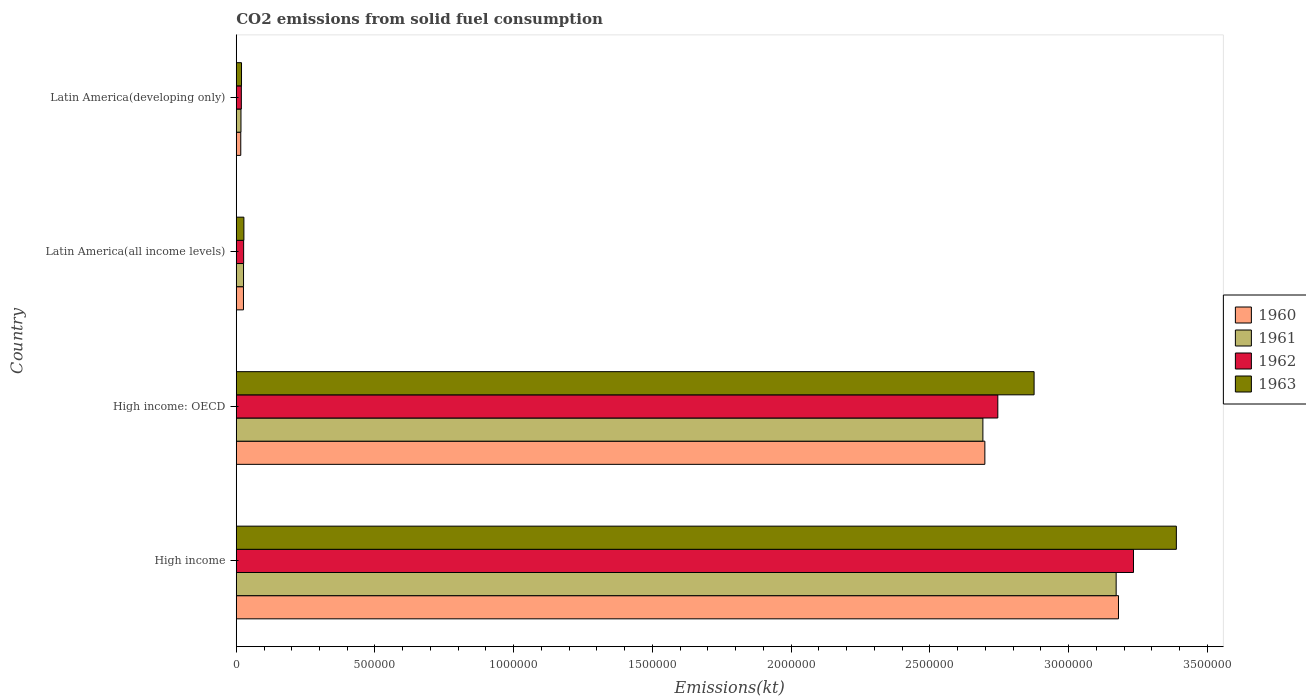How many different coloured bars are there?
Your response must be concise. 4. How many groups of bars are there?
Offer a terse response. 4. Are the number of bars per tick equal to the number of legend labels?
Offer a very short reply. Yes. How many bars are there on the 3rd tick from the top?
Give a very brief answer. 4. What is the label of the 2nd group of bars from the top?
Make the answer very short. Latin America(all income levels). What is the amount of CO2 emitted in 1960 in Latin America(all income levels)?
Offer a terse response. 2.60e+04. Across all countries, what is the maximum amount of CO2 emitted in 1960?
Offer a very short reply. 3.18e+06. Across all countries, what is the minimum amount of CO2 emitted in 1961?
Ensure brevity in your answer.  1.70e+04. In which country was the amount of CO2 emitted in 1961 minimum?
Give a very brief answer. Latin America(developing only). What is the total amount of CO2 emitted in 1960 in the graph?
Offer a terse response. 5.92e+06. What is the difference between the amount of CO2 emitted in 1960 in High income: OECD and that in Latin America(all income levels)?
Ensure brevity in your answer.  2.67e+06. What is the difference between the amount of CO2 emitted in 1960 in Latin America(all income levels) and the amount of CO2 emitted in 1962 in High income: OECD?
Keep it short and to the point. -2.72e+06. What is the average amount of CO2 emitted in 1962 per country?
Provide a short and direct response. 1.51e+06. What is the difference between the amount of CO2 emitted in 1961 and amount of CO2 emitted in 1963 in Latin America(developing only)?
Your answer should be very brief. -1990.54. In how many countries, is the amount of CO2 emitted in 1962 greater than 1500000 kt?
Offer a terse response. 2. What is the ratio of the amount of CO2 emitted in 1963 in High income to that in High income: OECD?
Ensure brevity in your answer.  1.18. What is the difference between the highest and the second highest amount of CO2 emitted in 1962?
Offer a very short reply. 4.89e+05. What is the difference between the highest and the lowest amount of CO2 emitted in 1960?
Offer a very short reply. 3.16e+06. In how many countries, is the amount of CO2 emitted in 1963 greater than the average amount of CO2 emitted in 1963 taken over all countries?
Ensure brevity in your answer.  2. Is the sum of the amount of CO2 emitted in 1962 in High income: OECD and Latin America(developing only) greater than the maximum amount of CO2 emitted in 1963 across all countries?
Make the answer very short. No. Are all the bars in the graph horizontal?
Your response must be concise. Yes. How many countries are there in the graph?
Your answer should be compact. 4. Does the graph contain grids?
Keep it short and to the point. No. Where does the legend appear in the graph?
Offer a very short reply. Center right. How are the legend labels stacked?
Give a very brief answer. Vertical. What is the title of the graph?
Make the answer very short. CO2 emissions from solid fuel consumption. What is the label or title of the X-axis?
Make the answer very short. Emissions(kt). What is the label or title of the Y-axis?
Provide a succinct answer. Country. What is the Emissions(kt) of 1960 in High income?
Offer a very short reply. 3.18e+06. What is the Emissions(kt) of 1961 in High income?
Keep it short and to the point. 3.17e+06. What is the Emissions(kt) of 1962 in High income?
Offer a terse response. 3.23e+06. What is the Emissions(kt) in 1963 in High income?
Your response must be concise. 3.39e+06. What is the Emissions(kt) of 1960 in High income: OECD?
Your answer should be compact. 2.70e+06. What is the Emissions(kt) in 1961 in High income: OECD?
Give a very brief answer. 2.69e+06. What is the Emissions(kt) in 1962 in High income: OECD?
Your answer should be compact. 2.75e+06. What is the Emissions(kt) of 1963 in High income: OECD?
Your response must be concise. 2.88e+06. What is the Emissions(kt) in 1960 in Latin America(all income levels)?
Your answer should be very brief. 2.60e+04. What is the Emissions(kt) of 1961 in Latin America(all income levels)?
Your answer should be compact. 2.63e+04. What is the Emissions(kt) in 1962 in Latin America(all income levels)?
Make the answer very short. 2.67e+04. What is the Emissions(kt) in 1963 in Latin America(all income levels)?
Your answer should be compact. 2.75e+04. What is the Emissions(kt) of 1960 in Latin America(developing only)?
Provide a short and direct response. 1.62e+04. What is the Emissions(kt) in 1961 in Latin America(developing only)?
Offer a terse response. 1.70e+04. What is the Emissions(kt) in 1962 in Latin America(developing only)?
Make the answer very short. 1.83e+04. What is the Emissions(kt) in 1963 in Latin America(developing only)?
Your response must be concise. 1.90e+04. Across all countries, what is the maximum Emissions(kt) in 1960?
Your response must be concise. 3.18e+06. Across all countries, what is the maximum Emissions(kt) of 1961?
Your answer should be very brief. 3.17e+06. Across all countries, what is the maximum Emissions(kt) of 1962?
Ensure brevity in your answer.  3.23e+06. Across all countries, what is the maximum Emissions(kt) in 1963?
Offer a very short reply. 3.39e+06. Across all countries, what is the minimum Emissions(kt) of 1960?
Give a very brief answer. 1.62e+04. Across all countries, what is the minimum Emissions(kt) of 1961?
Your answer should be very brief. 1.70e+04. Across all countries, what is the minimum Emissions(kt) of 1962?
Your answer should be very brief. 1.83e+04. Across all countries, what is the minimum Emissions(kt) of 1963?
Make the answer very short. 1.90e+04. What is the total Emissions(kt) of 1960 in the graph?
Offer a terse response. 5.92e+06. What is the total Emissions(kt) of 1961 in the graph?
Give a very brief answer. 5.91e+06. What is the total Emissions(kt) of 1962 in the graph?
Your response must be concise. 6.02e+06. What is the total Emissions(kt) of 1963 in the graph?
Offer a terse response. 6.31e+06. What is the difference between the Emissions(kt) in 1960 in High income and that in High income: OECD?
Your answer should be very brief. 4.82e+05. What is the difference between the Emissions(kt) of 1961 in High income and that in High income: OECD?
Your answer should be compact. 4.80e+05. What is the difference between the Emissions(kt) of 1962 in High income and that in High income: OECD?
Offer a terse response. 4.89e+05. What is the difference between the Emissions(kt) of 1963 in High income and that in High income: OECD?
Your answer should be very brief. 5.13e+05. What is the difference between the Emissions(kt) of 1960 in High income and that in Latin America(all income levels)?
Make the answer very short. 3.15e+06. What is the difference between the Emissions(kt) in 1961 in High income and that in Latin America(all income levels)?
Offer a terse response. 3.15e+06. What is the difference between the Emissions(kt) in 1962 in High income and that in Latin America(all income levels)?
Offer a very short reply. 3.21e+06. What is the difference between the Emissions(kt) in 1963 in High income and that in Latin America(all income levels)?
Your answer should be very brief. 3.36e+06. What is the difference between the Emissions(kt) in 1960 in High income and that in Latin America(developing only)?
Offer a terse response. 3.16e+06. What is the difference between the Emissions(kt) of 1961 in High income and that in Latin America(developing only)?
Your response must be concise. 3.15e+06. What is the difference between the Emissions(kt) in 1962 in High income and that in Latin America(developing only)?
Your answer should be very brief. 3.22e+06. What is the difference between the Emissions(kt) of 1963 in High income and that in Latin America(developing only)?
Your answer should be compact. 3.37e+06. What is the difference between the Emissions(kt) in 1960 in High income: OECD and that in Latin America(all income levels)?
Offer a very short reply. 2.67e+06. What is the difference between the Emissions(kt) in 1961 in High income: OECD and that in Latin America(all income levels)?
Make the answer very short. 2.67e+06. What is the difference between the Emissions(kt) in 1962 in High income: OECD and that in Latin America(all income levels)?
Provide a succinct answer. 2.72e+06. What is the difference between the Emissions(kt) in 1963 in High income: OECD and that in Latin America(all income levels)?
Ensure brevity in your answer.  2.85e+06. What is the difference between the Emissions(kt) of 1960 in High income: OECD and that in Latin America(developing only)?
Provide a succinct answer. 2.68e+06. What is the difference between the Emissions(kt) of 1961 in High income: OECD and that in Latin America(developing only)?
Offer a very short reply. 2.67e+06. What is the difference between the Emissions(kt) in 1962 in High income: OECD and that in Latin America(developing only)?
Your response must be concise. 2.73e+06. What is the difference between the Emissions(kt) in 1963 in High income: OECD and that in Latin America(developing only)?
Your answer should be very brief. 2.86e+06. What is the difference between the Emissions(kt) of 1960 in Latin America(all income levels) and that in Latin America(developing only)?
Your answer should be very brief. 9759.8. What is the difference between the Emissions(kt) in 1961 in Latin America(all income levels) and that in Latin America(developing only)?
Offer a very short reply. 9282.45. What is the difference between the Emissions(kt) of 1962 in Latin America(all income levels) and that in Latin America(developing only)?
Your response must be concise. 8301.83. What is the difference between the Emissions(kt) in 1963 in Latin America(all income levels) and that in Latin America(developing only)?
Give a very brief answer. 8542.91. What is the difference between the Emissions(kt) in 1960 in High income and the Emissions(kt) in 1961 in High income: OECD?
Your answer should be very brief. 4.89e+05. What is the difference between the Emissions(kt) in 1960 in High income and the Emissions(kt) in 1962 in High income: OECD?
Provide a short and direct response. 4.35e+05. What is the difference between the Emissions(kt) of 1960 in High income and the Emissions(kt) of 1963 in High income: OECD?
Make the answer very short. 3.04e+05. What is the difference between the Emissions(kt) in 1961 in High income and the Emissions(kt) in 1962 in High income: OECD?
Offer a terse response. 4.27e+05. What is the difference between the Emissions(kt) of 1961 in High income and the Emissions(kt) of 1963 in High income: OECD?
Ensure brevity in your answer.  2.96e+05. What is the difference between the Emissions(kt) of 1962 in High income and the Emissions(kt) of 1963 in High income: OECD?
Ensure brevity in your answer.  3.58e+05. What is the difference between the Emissions(kt) of 1960 in High income and the Emissions(kt) of 1961 in Latin America(all income levels)?
Make the answer very short. 3.15e+06. What is the difference between the Emissions(kt) of 1960 in High income and the Emissions(kt) of 1962 in Latin America(all income levels)?
Your answer should be compact. 3.15e+06. What is the difference between the Emissions(kt) in 1960 in High income and the Emissions(kt) in 1963 in Latin America(all income levels)?
Ensure brevity in your answer.  3.15e+06. What is the difference between the Emissions(kt) in 1961 in High income and the Emissions(kt) in 1962 in Latin America(all income levels)?
Your answer should be compact. 3.15e+06. What is the difference between the Emissions(kt) in 1961 in High income and the Emissions(kt) in 1963 in Latin America(all income levels)?
Provide a succinct answer. 3.14e+06. What is the difference between the Emissions(kt) in 1962 in High income and the Emissions(kt) in 1963 in Latin America(all income levels)?
Offer a terse response. 3.21e+06. What is the difference between the Emissions(kt) of 1960 in High income and the Emissions(kt) of 1961 in Latin America(developing only)?
Your answer should be compact. 3.16e+06. What is the difference between the Emissions(kt) in 1960 in High income and the Emissions(kt) in 1962 in Latin America(developing only)?
Offer a terse response. 3.16e+06. What is the difference between the Emissions(kt) of 1960 in High income and the Emissions(kt) of 1963 in Latin America(developing only)?
Provide a short and direct response. 3.16e+06. What is the difference between the Emissions(kt) in 1961 in High income and the Emissions(kt) in 1962 in Latin America(developing only)?
Provide a succinct answer. 3.15e+06. What is the difference between the Emissions(kt) of 1961 in High income and the Emissions(kt) of 1963 in Latin America(developing only)?
Keep it short and to the point. 3.15e+06. What is the difference between the Emissions(kt) in 1962 in High income and the Emissions(kt) in 1963 in Latin America(developing only)?
Offer a terse response. 3.22e+06. What is the difference between the Emissions(kt) in 1960 in High income: OECD and the Emissions(kt) in 1961 in Latin America(all income levels)?
Offer a very short reply. 2.67e+06. What is the difference between the Emissions(kt) of 1960 in High income: OECD and the Emissions(kt) of 1962 in Latin America(all income levels)?
Offer a very short reply. 2.67e+06. What is the difference between the Emissions(kt) in 1960 in High income: OECD and the Emissions(kt) in 1963 in Latin America(all income levels)?
Give a very brief answer. 2.67e+06. What is the difference between the Emissions(kt) in 1961 in High income: OECD and the Emissions(kt) in 1962 in Latin America(all income levels)?
Your answer should be very brief. 2.66e+06. What is the difference between the Emissions(kt) of 1961 in High income: OECD and the Emissions(kt) of 1963 in Latin America(all income levels)?
Provide a short and direct response. 2.66e+06. What is the difference between the Emissions(kt) in 1962 in High income: OECD and the Emissions(kt) in 1963 in Latin America(all income levels)?
Your answer should be compact. 2.72e+06. What is the difference between the Emissions(kt) of 1960 in High income: OECD and the Emissions(kt) of 1961 in Latin America(developing only)?
Offer a very short reply. 2.68e+06. What is the difference between the Emissions(kt) of 1960 in High income: OECD and the Emissions(kt) of 1962 in Latin America(developing only)?
Make the answer very short. 2.68e+06. What is the difference between the Emissions(kt) of 1960 in High income: OECD and the Emissions(kt) of 1963 in Latin America(developing only)?
Make the answer very short. 2.68e+06. What is the difference between the Emissions(kt) of 1961 in High income: OECD and the Emissions(kt) of 1962 in Latin America(developing only)?
Keep it short and to the point. 2.67e+06. What is the difference between the Emissions(kt) of 1961 in High income: OECD and the Emissions(kt) of 1963 in Latin America(developing only)?
Your answer should be very brief. 2.67e+06. What is the difference between the Emissions(kt) in 1962 in High income: OECD and the Emissions(kt) in 1963 in Latin America(developing only)?
Ensure brevity in your answer.  2.73e+06. What is the difference between the Emissions(kt) of 1960 in Latin America(all income levels) and the Emissions(kt) of 1961 in Latin America(developing only)?
Offer a terse response. 9031.46. What is the difference between the Emissions(kt) of 1960 in Latin America(all income levels) and the Emissions(kt) of 1962 in Latin America(developing only)?
Provide a succinct answer. 7658.68. What is the difference between the Emissions(kt) in 1960 in Latin America(all income levels) and the Emissions(kt) in 1963 in Latin America(developing only)?
Offer a very short reply. 7040.93. What is the difference between the Emissions(kt) in 1961 in Latin America(all income levels) and the Emissions(kt) in 1962 in Latin America(developing only)?
Make the answer very short. 7909.66. What is the difference between the Emissions(kt) of 1961 in Latin America(all income levels) and the Emissions(kt) of 1963 in Latin America(developing only)?
Keep it short and to the point. 7291.91. What is the difference between the Emissions(kt) in 1962 in Latin America(all income levels) and the Emissions(kt) in 1963 in Latin America(developing only)?
Give a very brief answer. 7684.07. What is the average Emissions(kt) of 1960 per country?
Provide a succinct answer. 1.48e+06. What is the average Emissions(kt) in 1961 per country?
Make the answer very short. 1.48e+06. What is the average Emissions(kt) in 1962 per country?
Make the answer very short. 1.51e+06. What is the average Emissions(kt) of 1963 per country?
Your response must be concise. 1.58e+06. What is the difference between the Emissions(kt) in 1960 and Emissions(kt) in 1961 in High income?
Keep it short and to the point. 8354.42. What is the difference between the Emissions(kt) of 1960 and Emissions(kt) of 1962 in High income?
Your response must be concise. -5.41e+04. What is the difference between the Emissions(kt) in 1960 and Emissions(kt) in 1963 in High income?
Make the answer very short. -2.09e+05. What is the difference between the Emissions(kt) of 1961 and Emissions(kt) of 1962 in High income?
Offer a terse response. -6.24e+04. What is the difference between the Emissions(kt) of 1961 and Emissions(kt) of 1963 in High income?
Offer a terse response. -2.17e+05. What is the difference between the Emissions(kt) in 1962 and Emissions(kt) in 1963 in High income?
Make the answer very short. -1.55e+05. What is the difference between the Emissions(kt) in 1960 and Emissions(kt) in 1961 in High income: OECD?
Offer a very short reply. 7090.26. What is the difference between the Emissions(kt) in 1960 and Emissions(kt) in 1962 in High income: OECD?
Your response must be concise. -4.67e+04. What is the difference between the Emissions(kt) of 1960 and Emissions(kt) of 1963 in High income: OECD?
Provide a succinct answer. -1.77e+05. What is the difference between the Emissions(kt) of 1961 and Emissions(kt) of 1962 in High income: OECD?
Give a very brief answer. -5.38e+04. What is the difference between the Emissions(kt) of 1961 and Emissions(kt) of 1963 in High income: OECD?
Offer a very short reply. -1.85e+05. What is the difference between the Emissions(kt) in 1962 and Emissions(kt) in 1963 in High income: OECD?
Your response must be concise. -1.31e+05. What is the difference between the Emissions(kt) in 1960 and Emissions(kt) in 1961 in Latin America(all income levels)?
Keep it short and to the point. -250.98. What is the difference between the Emissions(kt) in 1960 and Emissions(kt) in 1962 in Latin America(all income levels)?
Make the answer very short. -643.15. What is the difference between the Emissions(kt) in 1960 and Emissions(kt) in 1963 in Latin America(all income levels)?
Offer a terse response. -1501.98. What is the difference between the Emissions(kt) of 1961 and Emissions(kt) of 1962 in Latin America(all income levels)?
Your answer should be compact. -392.16. What is the difference between the Emissions(kt) of 1961 and Emissions(kt) of 1963 in Latin America(all income levels)?
Offer a terse response. -1251. What is the difference between the Emissions(kt) in 1962 and Emissions(kt) in 1963 in Latin America(all income levels)?
Give a very brief answer. -858.84. What is the difference between the Emissions(kt) of 1960 and Emissions(kt) of 1961 in Latin America(developing only)?
Keep it short and to the point. -728.34. What is the difference between the Emissions(kt) of 1960 and Emissions(kt) of 1962 in Latin America(developing only)?
Offer a terse response. -2101.12. What is the difference between the Emissions(kt) in 1960 and Emissions(kt) in 1963 in Latin America(developing only)?
Your response must be concise. -2718.88. What is the difference between the Emissions(kt) in 1961 and Emissions(kt) in 1962 in Latin America(developing only)?
Your answer should be compact. -1372.79. What is the difference between the Emissions(kt) of 1961 and Emissions(kt) of 1963 in Latin America(developing only)?
Offer a very short reply. -1990.54. What is the difference between the Emissions(kt) of 1962 and Emissions(kt) of 1963 in Latin America(developing only)?
Give a very brief answer. -617.75. What is the ratio of the Emissions(kt) of 1960 in High income to that in High income: OECD?
Give a very brief answer. 1.18. What is the ratio of the Emissions(kt) of 1961 in High income to that in High income: OECD?
Ensure brevity in your answer.  1.18. What is the ratio of the Emissions(kt) in 1962 in High income to that in High income: OECD?
Offer a terse response. 1.18. What is the ratio of the Emissions(kt) of 1963 in High income to that in High income: OECD?
Provide a short and direct response. 1.18. What is the ratio of the Emissions(kt) of 1960 in High income to that in Latin America(all income levels)?
Ensure brevity in your answer.  122.27. What is the ratio of the Emissions(kt) of 1961 in High income to that in Latin America(all income levels)?
Your answer should be very brief. 120.78. What is the ratio of the Emissions(kt) of 1962 in High income to that in Latin America(all income levels)?
Ensure brevity in your answer.  121.35. What is the ratio of the Emissions(kt) of 1963 in High income to that in Latin America(all income levels)?
Keep it short and to the point. 123.18. What is the ratio of the Emissions(kt) in 1960 in High income to that in Latin America(developing only)?
Offer a very short reply. 195.71. What is the ratio of the Emissions(kt) in 1961 in High income to that in Latin America(developing only)?
Provide a short and direct response. 186.83. What is the ratio of the Emissions(kt) in 1962 in High income to that in Latin America(developing only)?
Ensure brevity in your answer.  176.25. What is the ratio of the Emissions(kt) of 1963 in High income to that in Latin America(developing only)?
Your answer should be compact. 178.66. What is the ratio of the Emissions(kt) of 1960 in High income: OECD to that in Latin America(all income levels)?
Provide a succinct answer. 103.75. What is the ratio of the Emissions(kt) in 1961 in High income: OECD to that in Latin America(all income levels)?
Provide a succinct answer. 102.49. What is the ratio of the Emissions(kt) of 1962 in High income: OECD to that in Latin America(all income levels)?
Your response must be concise. 103. What is the ratio of the Emissions(kt) in 1963 in High income: OECD to that in Latin America(all income levels)?
Your response must be concise. 104.54. What is the ratio of the Emissions(kt) of 1960 in High income: OECD to that in Latin America(developing only)?
Ensure brevity in your answer.  166.07. What is the ratio of the Emissions(kt) in 1961 in High income: OECD to that in Latin America(developing only)?
Your response must be concise. 158.53. What is the ratio of the Emissions(kt) in 1962 in High income: OECD to that in Latin America(developing only)?
Offer a terse response. 149.6. What is the ratio of the Emissions(kt) in 1963 in High income: OECD to that in Latin America(developing only)?
Your response must be concise. 151.62. What is the ratio of the Emissions(kt) in 1960 in Latin America(all income levels) to that in Latin America(developing only)?
Your response must be concise. 1.6. What is the ratio of the Emissions(kt) of 1961 in Latin America(all income levels) to that in Latin America(developing only)?
Provide a succinct answer. 1.55. What is the ratio of the Emissions(kt) in 1962 in Latin America(all income levels) to that in Latin America(developing only)?
Provide a short and direct response. 1.45. What is the ratio of the Emissions(kt) of 1963 in Latin America(all income levels) to that in Latin America(developing only)?
Ensure brevity in your answer.  1.45. What is the difference between the highest and the second highest Emissions(kt) in 1960?
Your answer should be compact. 4.82e+05. What is the difference between the highest and the second highest Emissions(kt) of 1961?
Provide a succinct answer. 4.80e+05. What is the difference between the highest and the second highest Emissions(kt) of 1962?
Ensure brevity in your answer.  4.89e+05. What is the difference between the highest and the second highest Emissions(kt) in 1963?
Make the answer very short. 5.13e+05. What is the difference between the highest and the lowest Emissions(kt) of 1960?
Your response must be concise. 3.16e+06. What is the difference between the highest and the lowest Emissions(kt) in 1961?
Provide a succinct answer. 3.15e+06. What is the difference between the highest and the lowest Emissions(kt) of 1962?
Offer a very short reply. 3.22e+06. What is the difference between the highest and the lowest Emissions(kt) of 1963?
Offer a very short reply. 3.37e+06. 